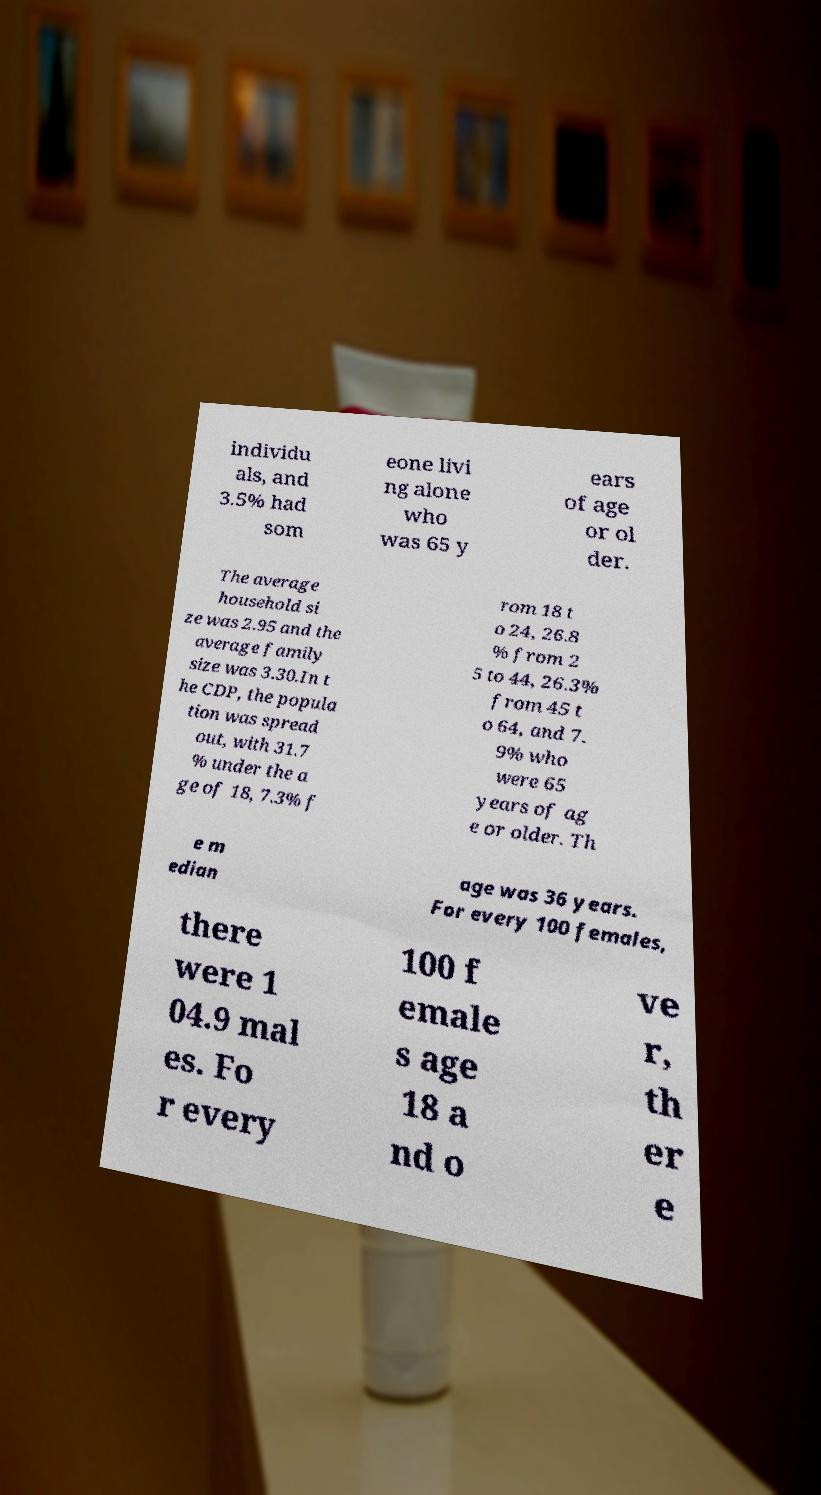There's text embedded in this image that I need extracted. Can you transcribe it verbatim? individu als, and 3.5% had som eone livi ng alone who was 65 y ears of age or ol der. The average household si ze was 2.95 and the average family size was 3.30.In t he CDP, the popula tion was spread out, with 31.7 % under the a ge of 18, 7.3% f rom 18 t o 24, 26.8 % from 2 5 to 44, 26.3% from 45 t o 64, and 7. 9% who were 65 years of ag e or older. Th e m edian age was 36 years. For every 100 females, there were 1 04.9 mal es. Fo r every 100 f emale s age 18 a nd o ve r, th er e 